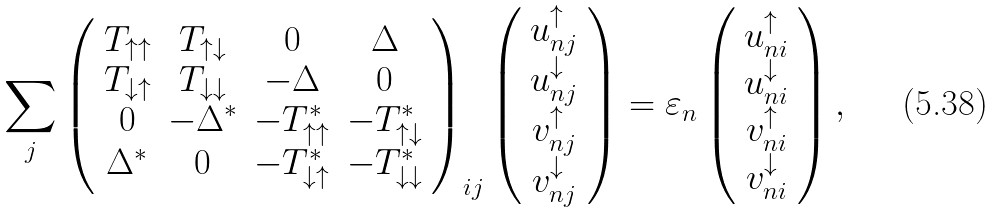<formula> <loc_0><loc_0><loc_500><loc_500>\sum _ { j } \left ( \begin{array} { c c c c } T _ { \uparrow \uparrow } & T _ { \uparrow \downarrow } & 0 & \Delta \\ T _ { \downarrow \uparrow } & T _ { \downarrow \downarrow } & - \Delta & 0 \\ 0 & - \Delta ^ { * } & - T _ { \uparrow \uparrow } ^ { * } & - T _ { \uparrow \downarrow } ^ { * } \\ \Delta ^ { * } & 0 & - T _ { \downarrow \uparrow } ^ { * } & - T _ { \downarrow \downarrow } ^ { * } \end{array} \right ) _ { i j } & \left ( \begin{array} { c } u _ { n j } ^ { \uparrow } \\ u _ { n j } ^ { \downarrow } \\ v _ { n j } ^ { \uparrow } \\ v _ { n j } ^ { \downarrow } \end{array} \right ) = \varepsilon _ { n } \left ( \begin{array} { c } u _ { n i } ^ { \uparrow } \\ u _ { n i } ^ { \downarrow } \\ v _ { n i } ^ { \uparrow } \\ v _ { n i } ^ { \downarrow } \end{array} \right ) ,</formula> 